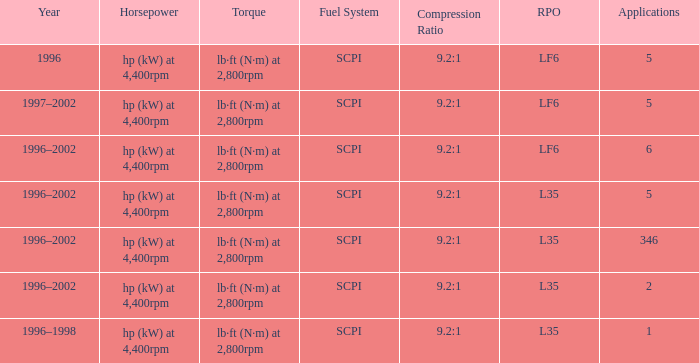What is the compaction proportion of the model with l35 rpo and 5 applications? 9.2:1. 